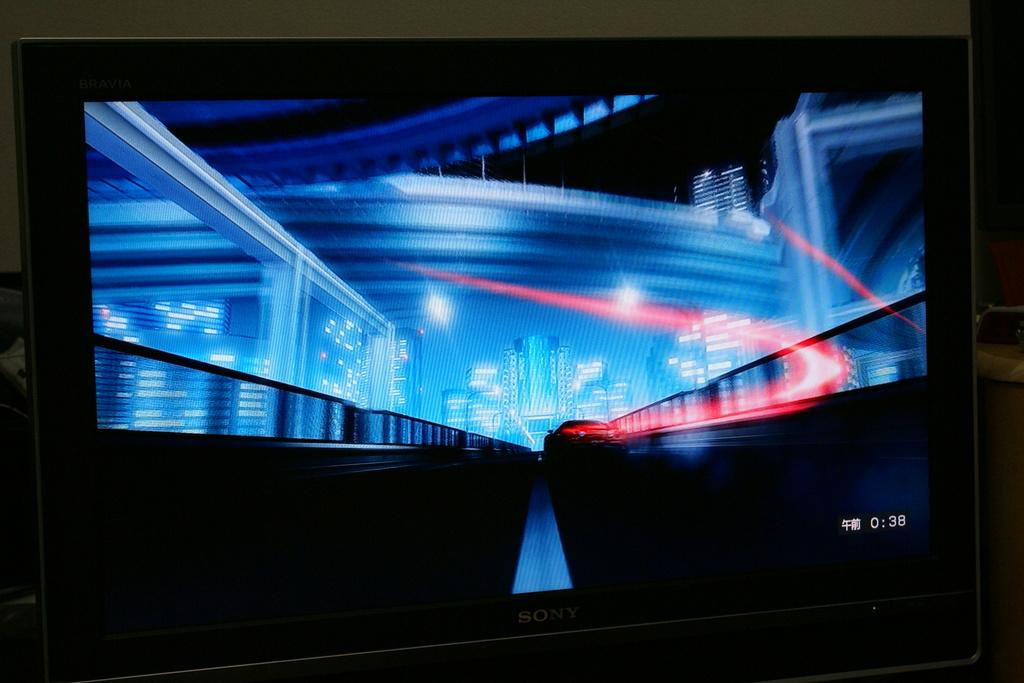<image>
Describe the image concisely. dark screen with blue and red patterns on it and 0:38 in the bottom right corner 